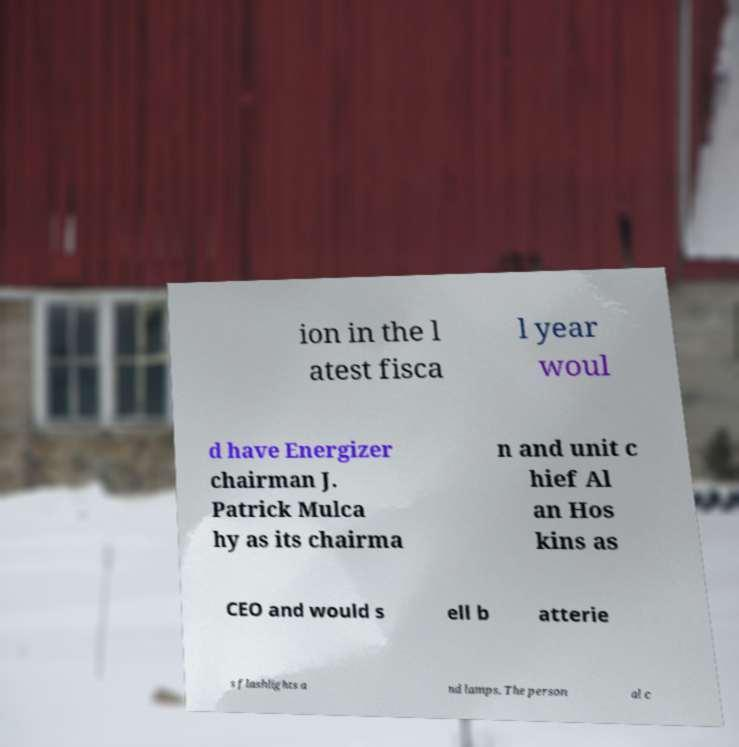Could you assist in decoding the text presented in this image and type it out clearly? ion in the l atest fisca l year woul d have Energizer chairman J. Patrick Mulca hy as its chairma n and unit c hief Al an Hos kins as CEO and would s ell b atterie s flashlights a nd lamps. The person al c 